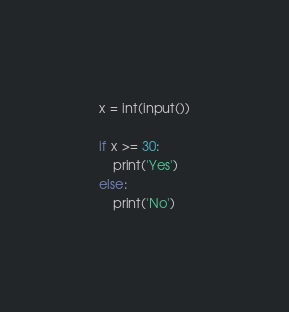<code> <loc_0><loc_0><loc_500><loc_500><_Python_>x = int(input())

if x >= 30:
    print('Yes')
else:
    print('No')
</code> 